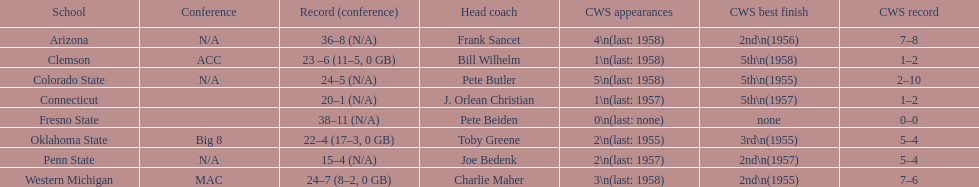How many teams had their cws best finish in 1955? 3. 